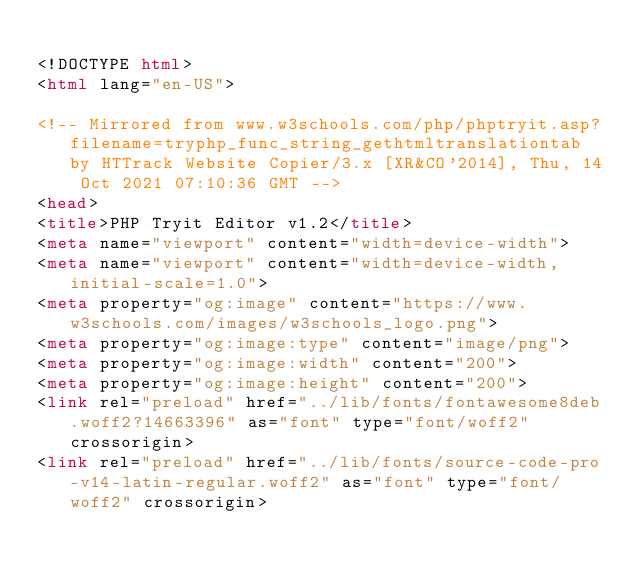<code> <loc_0><loc_0><loc_500><loc_500><_HTML_>
<!DOCTYPE html>
<html lang="en-US">

<!-- Mirrored from www.w3schools.com/php/phptryit.asp?filename=tryphp_func_string_gethtmltranslationtab by HTTrack Website Copier/3.x [XR&CO'2014], Thu, 14 Oct 2021 07:10:36 GMT -->
<head>
<title>PHP Tryit Editor v1.2</title>
<meta name="viewport" content="width=device-width">
<meta name="viewport" content="width=device-width, initial-scale=1.0">
<meta property="og:image" content="https://www.w3schools.com/images/w3schools_logo.png">
<meta property="og:image:type" content="image/png">
<meta property="og:image:width" content="200">
<meta property="og:image:height" content="200">
<link rel="preload" href="../lib/fonts/fontawesome8deb.woff2?14663396" as="font" type="font/woff2" crossorigin> 
<link rel="preload" href="../lib/fonts/source-code-pro-v14-latin-regular.woff2" as="font" type="font/woff2" crossorigin> </code> 